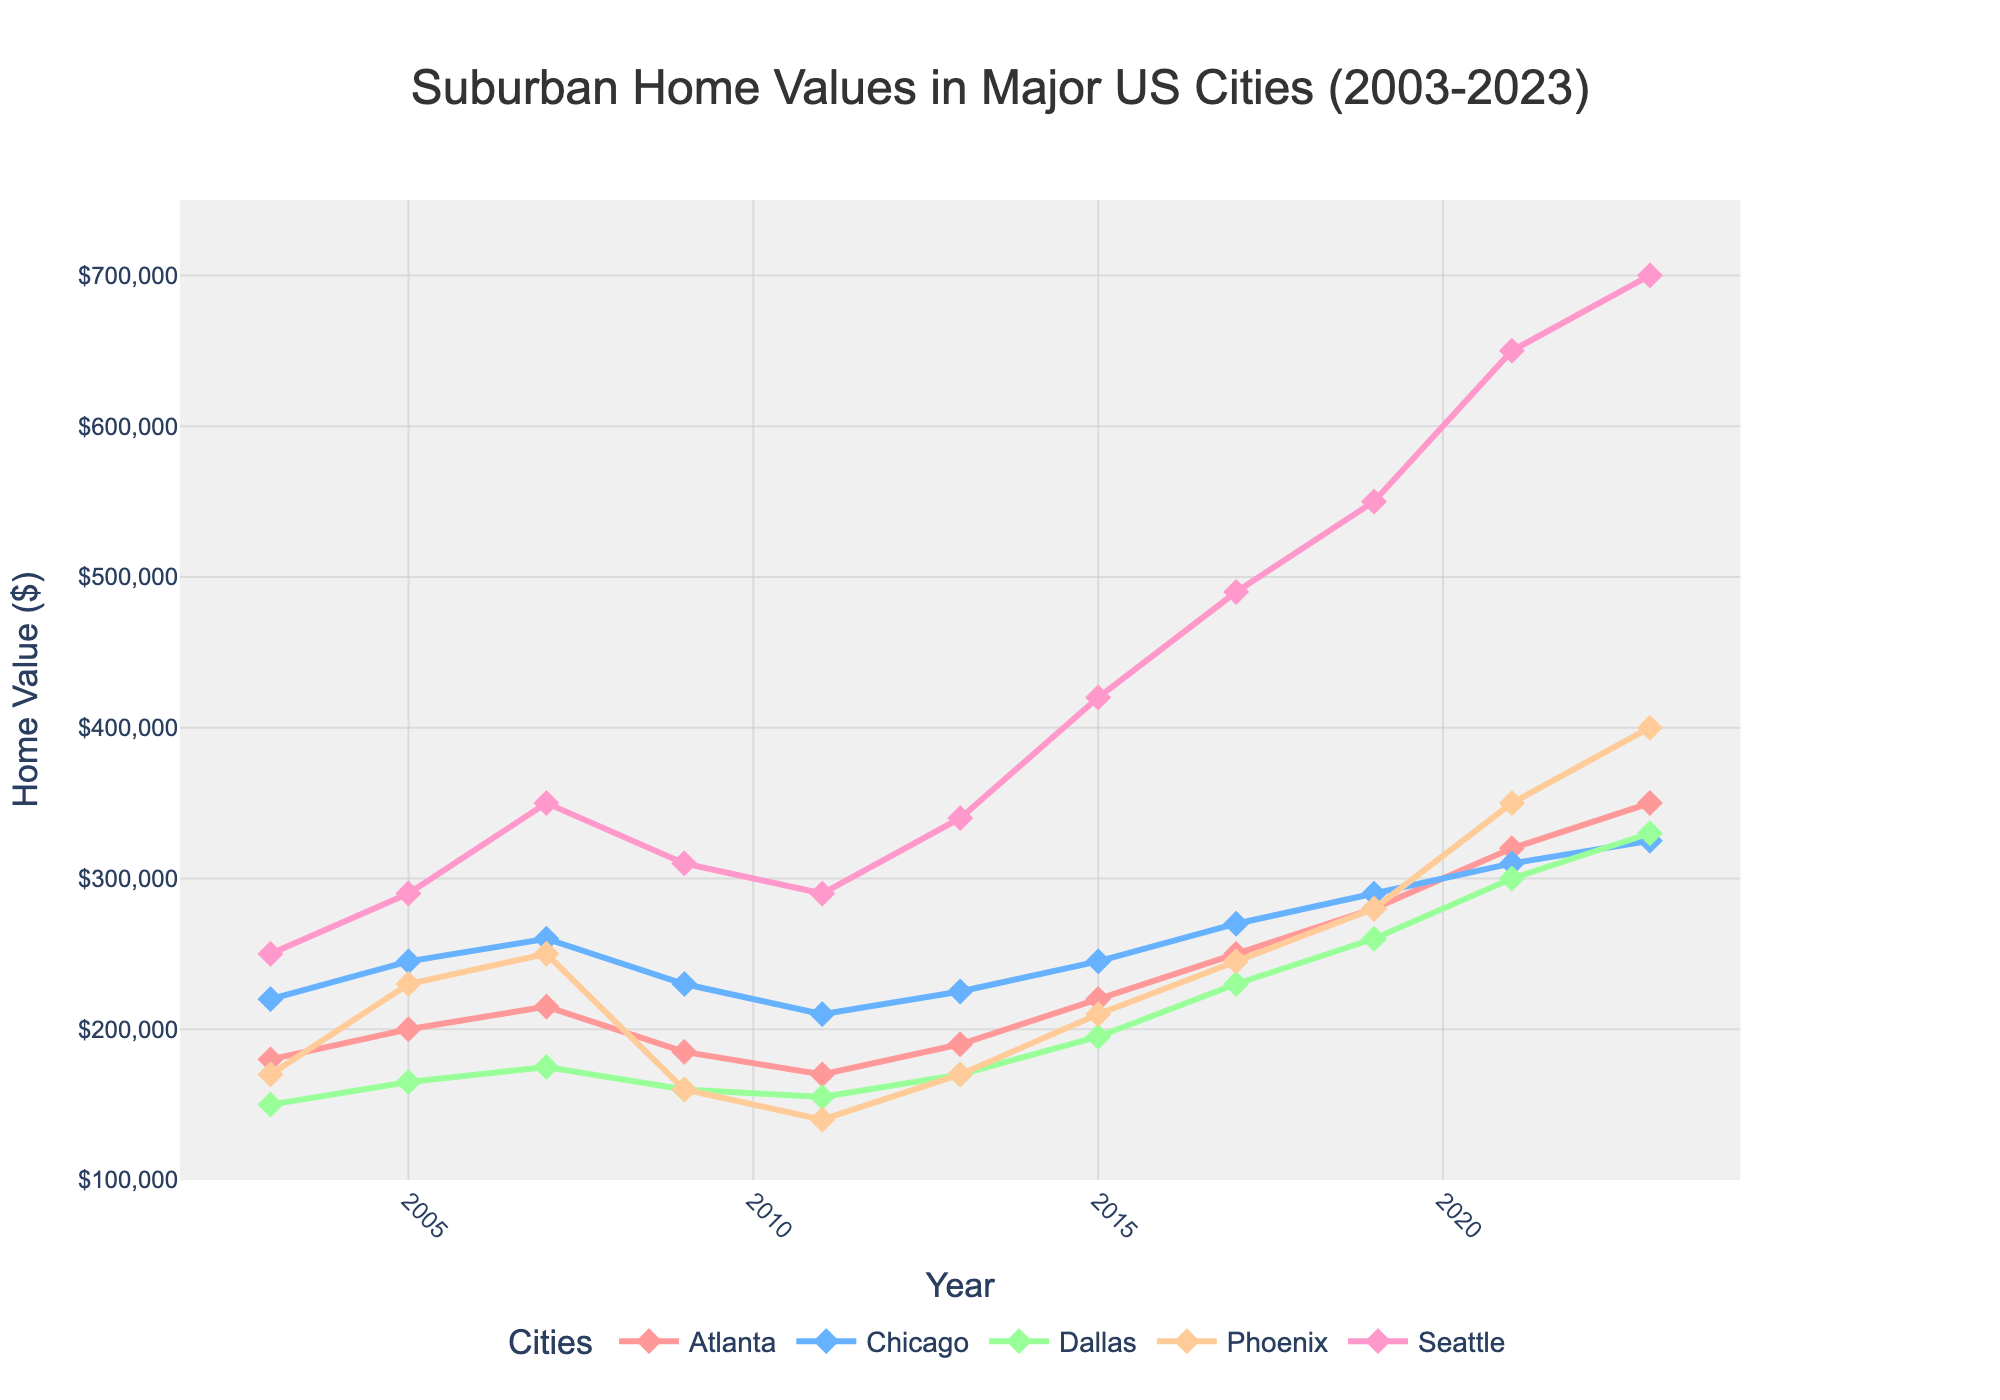what’s the home value in Atlanta in 2011? The home value in Atlanta in 2011 is represented by the red line. Check the value corresponding to the year 2011.
Answer: 170000 Which city had the highest home value in 2021? Look at the topmost line in the year 2021. The highest value color is dark pink, representing Seattle.
Answer: Seattle Which had a higher home value in 2005, Phoenix or Dallas? Compare the lines representing Phoenix and Dallas in 2005. The value for Phoenix is higher than that for Dallas.
Answer: Phoenix What is the difference in home value between Chicago and Dallas in 2023? Subtract the home value of Dallas from that of Chicago in 2023. Chicago: 325000, Dallas: 330000, Difference: 325000 - 330000 = -5000
Answer: -5000 In which year did Phoenix's home value exceed Atlanta's after 2003? Check the years after 2003; Phoenix's home value surpassed Atlanta's first time in 2021.
Answer: 2021 What is the average home value of Seattle from 2011 to 2023? Add the values of Seattle from 2011, 2013, 2015, 2017, 2019, 2021, and 2023 and then divide by 7. (290000 + 340000 + 420000 + 490000 + 550000 + 650000 + 700000)/7 = 2060500/7 = 294357
Answer: 294357 Did Atlanta's home value increase every year from 2003 to 2023? Check each year's value for Atlanta from 2003 to 2023 and see if it continuously increases. There are decreases in some years.
Answer: No How much did the home value in Phoenix increase from 2011 to 2023? Subtract Phoenix's value in 2011 from its value in 2023. Increase: 400000 - 140000 = 260000
Answer: 260000 What is the trend of home values in Seattle from 2009 to 2023? Observe the curve for Seattle from 2009 to 2023; it steadily increases.
Answer: Increasing steadily 